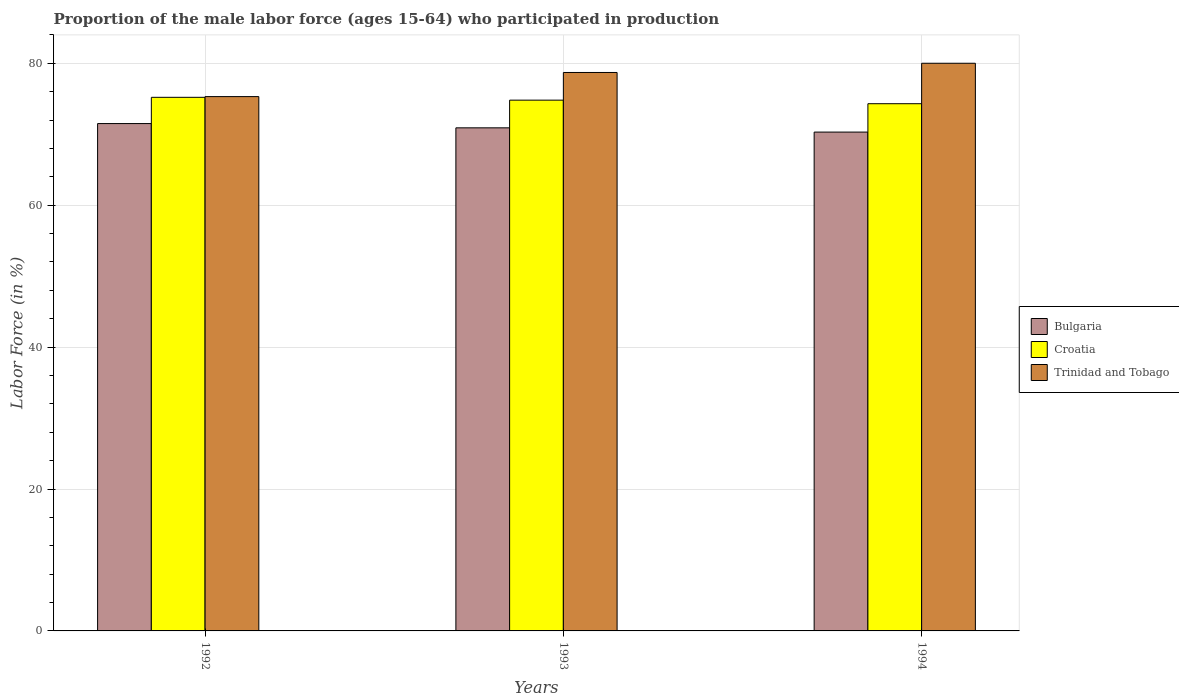How many groups of bars are there?
Offer a very short reply. 3. How many bars are there on the 2nd tick from the left?
Your answer should be very brief. 3. In how many cases, is the number of bars for a given year not equal to the number of legend labels?
Ensure brevity in your answer.  0. What is the proportion of the male labor force who participated in production in Bulgaria in 1992?
Provide a short and direct response. 71.5. Across all years, what is the maximum proportion of the male labor force who participated in production in Bulgaria?
Your answer should be compact. 71.5. Across all years, what is the minimum proportion of the male labor force who participated in production in Croatia?
Your answer should be compact. 74.3. In which year was the proportion of the male labor force who participated in production in Trinidad and Tobago minimum?
Make the answer very short. 1992. What is the total proportion of the male labor force who participated in production in Croatia in the graph?
Provide a succinct answer. 224.3. What is the difference between the proportion of the male labor force who participated in production in Croatia in 1992 and that in 1994?
Your answer should be very brief. 0.9. In the year 1992, what is the difference between the proportion of the male labor force who participated in production in Trinidad and Tobago and proportion of the male labor force who participated in production in Croatia?
Provide a short and direct response. 0.1. In how many years, is the proportion of the male labor force who participated in production in Bulgaria greater than 76 %?
Make the answer very short. 0. What is the ratio of the proportion of the male labor force who participated in production in Bulgaria in 1992 to that in 1994?
Your response must be concise. 1.02. Is the proportion of the male labor force who participated in production in Croatia in 1992 less than that in 1993?
Make the answer very short. No. Is the difference between the proportion of the male labor force who participated in production in Trinidad and Tobago in 1993 and 1994 greater than the difference between the proportion of the male labor force who participated in production in Croatia in 1993 and 1994?
Your response must be concise. No. What is the difference between the highest and the second highest proportion of the male labor force who participated in production in Bulgaria?
Keep it short and to the point. 0.6. What is the difference between the highest and the lowest proportion of the male labor force who participated in production in Trinidad and Tobago?
Provide a succinct answer. 4.7. Is the sum of the proportion of the male labor force who participated in production in Bulgaria in 1993 and 1994 greater than the maximum proportion of the male labor force who participated in production in Croatia across all years?
Provide a short and direct response. Yes. What does the 2nd bar from the left in 1994 represents?
Ensure brevity in your answer.  Croatia. What does the 1st bar from the right in 1994 represents?
Give a very brief answer. Trinidad and Tobago. Is it the case that in every year, the sum of the proportion of the male labor force who participated in production in Bulgaria and proportion of the male labor force who participated in production in Croatia is greater than the proportion of the male labor force who participated in production in Trinidad and Tobago?
Keep it short and to the point. Yes. How many years are there in the graph?
Your response must be concise. 3. Are the values on the major ticks of Y-axis written in scientific E-notation?
Offer a terse response. No. Does the graph contain any zero values?
Your response must be concise. No. How many legend labels are there?
Give a very brief answer. 3. How are the legend labels stacked?
Your answer should be very brief. Vertical. What is the title of the graph?
Offer a terse response. Proportion of the male labor force (ages 15-64) who participated in production. Does "New Caledonia" appear as one of the legend labels in the graph?
Your answer should be very brief. No. What is the Labor Force (in %) of Bulgaria in 1992?
Provide a succinct answer. 71.5. What is the Labor Force (in %) of Croatia in 1992?
Your answer should be very brief. 75.2. What is the Labor Force (in %) in Trinidad and Tobago in 1992?
Your answer should be very brief. 75.3. What is the Labor Force (in %) in Bulgaria in 1993?
Your answer should be very brief. 70.9. What is the Labor Force (in %) in Croatia in 1993?
Offer a terse response. 74.8. What is the Labor Force (in %) of Trinidad and Tobago in 1993?
Provide a succinct answer. 78.7. What is the Labor Force (in %) in Bulgaria in 1994?
Provide a short and direct response. 70.3. What is the Labor Force (in %) of Croatia in 1994?
Your answer should be very brief. 74.3. What is the Labor Force (in %) in Trinidad and Tobago in 1994?
Keep it short and to the point. 80. Across all years, what is the maximum Labor Force (in %) in Bulgaria?
Ensure brevity in your answer.  71.5. Across all years, what is the maximum Labor Force (in %) in Croatia?
Keep it short and to the point. 75.2. Across all years, what is the minimum Labor Force (in %) in Bulgaria?
Keep it short and to the point. 70.3. Across all years, what is the minimum Labor Force (in %) in Croatia?
Offer a terse response. 74.3. Across all years, what is the minimum Labor Force (in %) in Trinidad and Tobago?
Your response must be concise. 75.3. What is the total Labor Force (in %) in Bulgaria in the graph?
Keep it short and to the point. 212.7. What is the total Labor Force (in %) of Croatia in the graph?
Offer a terse response. 224.3. What is the total Labor Force (in %) of Trinidad and Tobago in the graph?
Offer a terse response. 234. What is the difference between the Labor Force (in %) in Bulgaria in 1992 and that in 1993?
Your answer should be very brief. 0.6. What is the difference between the Labor Force (in %) of Croatia in 1992 and that in 1994?
Make the answer very short. 0.9. What is the difference between the Labor Force (in %) in Bulgaria in 1993 and that in 1994?
Offer a terse response. 0.6. What is the difference between the Labor Force (in %) in Croatia in 1993 and that in 1994?
Offer a terse response. 0.5. What is the difference between the Labor Force (in %) of Trinidad and Tobago in 1993 and that in 1994?
Give a very brief answer. -1.3. What is the difference between the Labor Force (in %) in Croatia in 1992 and the Labor Force (in %) in Trinidad and Tobago in 1993?
Your response must be concise. -3.5. What is the difference between the Labor Force (in %) in Bulgaria in 1992 and the Labor Force (in %) in Croatia in 1994?
Give a very brief answer. -2.8. What is the difference between the Labor Force (in %) of Bulgaria in 1993 and the Labor Force (in %) of Croatia in 1994?
Provide a short and direct response. -3.4. What is the difference between the Labor Force (in %) of Bulgaria in 1993 and the Labor Force (in %) of Trinidad and Tobago in 1994?
Your answer should be compact. -9.1. What is the average Labor Force (in %) of Bulgaria per year?
Your answer should be very brief. 70.9. What is the average Labor Force (in %) in Croatia per year?
Ensure brevity in your answer.  74.77. In the year 1992, what is the difference between the Labor Force (in %) in Bulgaria and Labor Force (in %) in Trinidad and Tobago?
Your response must be concise. -3.8. In the year 1992, what is the difference between the Labor Force (in %) of Croatia and Labor Force (in %) of Trinidad and Tobago?
Offer a terse response. -0.1. In the year 1994, what is the difference between the Labor Force (in %) in Bulgaria and Labor Force (in %) in Trinidad and Tobago?
Provide a succinct answer. -9.7. What is the ratio of the Labor Force (in %) in Bulgaria in 1992 to that in 1993?
Offer a terse response. 1.01. What is the ratio of the Labor Force (in %) in Trinidad and Tobago in 1992 to that in 1993?
Offer a terse response. 0.96. What is the ratio of the Labor Force (in %) in Bulgaria in 1992 to that in 1994?
Give a very brief answer. 1.02. What is the ratio of the Labor Force (in %) of Croatia in 1992 to that in 1994?
Ensure brevity in your answer.  1.01. What is the ratio of the Labor Force (in %) of Trinidad and Tobago in 1992 to that in 1994?
Provide a short and direct response. 0.94. What is the ratio of the Labor Force (in %) in Bulgaria in 1993 to that in 1994?
Your answer should be compact. 1.01. What is the ratio of the Labor Force (in %) of Croatia in 1993 to that in 1994?
Make the answer very short. 1.01. What is the ratio of the Labor Force (in %) in Trinidad and Tobago in 1993 to that in 1994?
Keep it short and to the point. 0.98. 